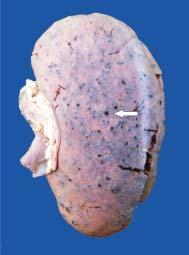what does the cortex show visible through the capsule?
Answer the question using a single word or phrase. Tiny petechial haemorrhages 